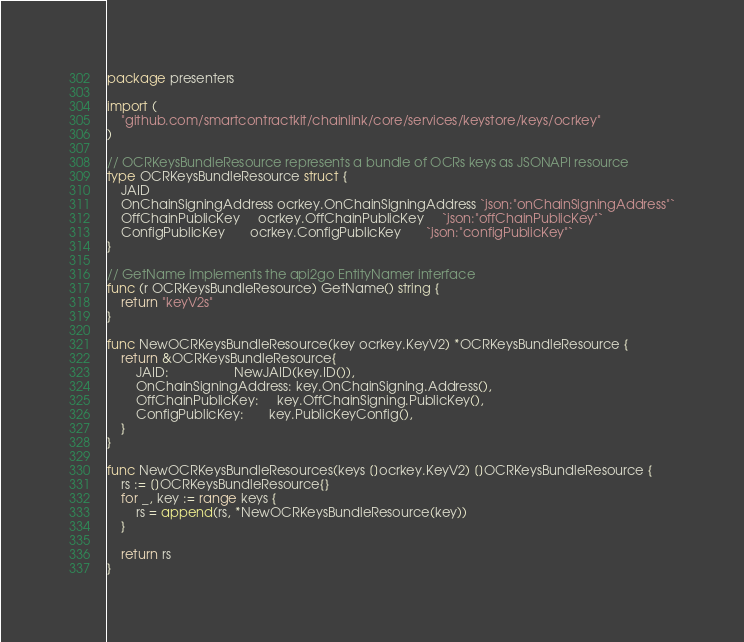<code> <loc_0><loc_0><loc_500><loc_500><_Go_>package presenters

import (
	"github.com/smartcontractkit/chainlink/core/services/keystore/keys/ocrkey"
)

// OCRKeysBundleResource represents a bundle of OCRs keys as JSONAPI resource
type OCRKeysBundleResource struct {
	JAID
	OnChainSigningAddress ocrkey.OnChainSigningAddress `json:"onChainSigningAddress"`
	OffChainPublicKey     ocrkey.OffChainPublicKey     `json:"offChainPublicKey"`
	ConfigPublicKey       ocrkey.ConfigPublicKey       `json:"configPublicKey"`
}

// GetName implements the api2go EntityNamer interface
func (r OCRKeysBundleResource) GetName() string {
	return "keyV2s"
}

func NewOCRKeysBundleResource(key ocrkey.KeyV2) *OCRKeysBundleResource {
	return &OCRKeysBundleResource{
		JAID:                  NewJAID(key.ID()),
		OnChainSigningAddress: key.OnChainSigning.Address(),
		OffChainPublicKey:     key.OffChainSigning.PublicKey(),
		ConfigPublicKey:       key.PublicKeyConfig(),
	}
}

func NewOCRKeysBundleResources(keys []ocrkey.KeyV2) []OCRKeysBundleResource {
	rs := []OCRKeysBundleResource{}
	for _, key := range keys {
		rs = append(rs, *NewOCRKeysBundleResource(key))
	}

	return rs
}
</code> 